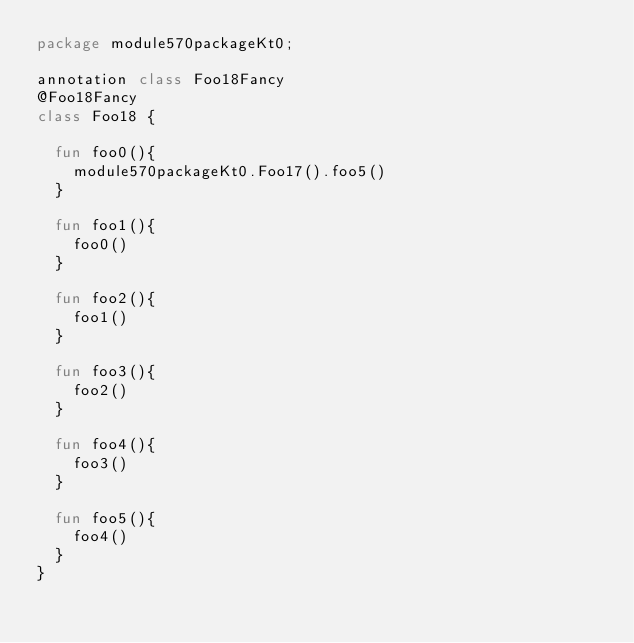<code> <loc_0><loc_0><loc_500><loc_500><_Kotlin_>package module570packageKt0;

annotation class Foo18Fancy
@Foo18Fancy
class Foo18 {

  fun foo0(){
    module570packageKt0.Foo17().foo5()
  }

  fun foo1(){
    foo0()
  }

  fun foo2(){
    foo1()
  }

  fun foo3(){
    foo2()
  }

  fun foo4(){
    foo3()
  }

  fun foo5(){
    foo4()
  }
}</code> 